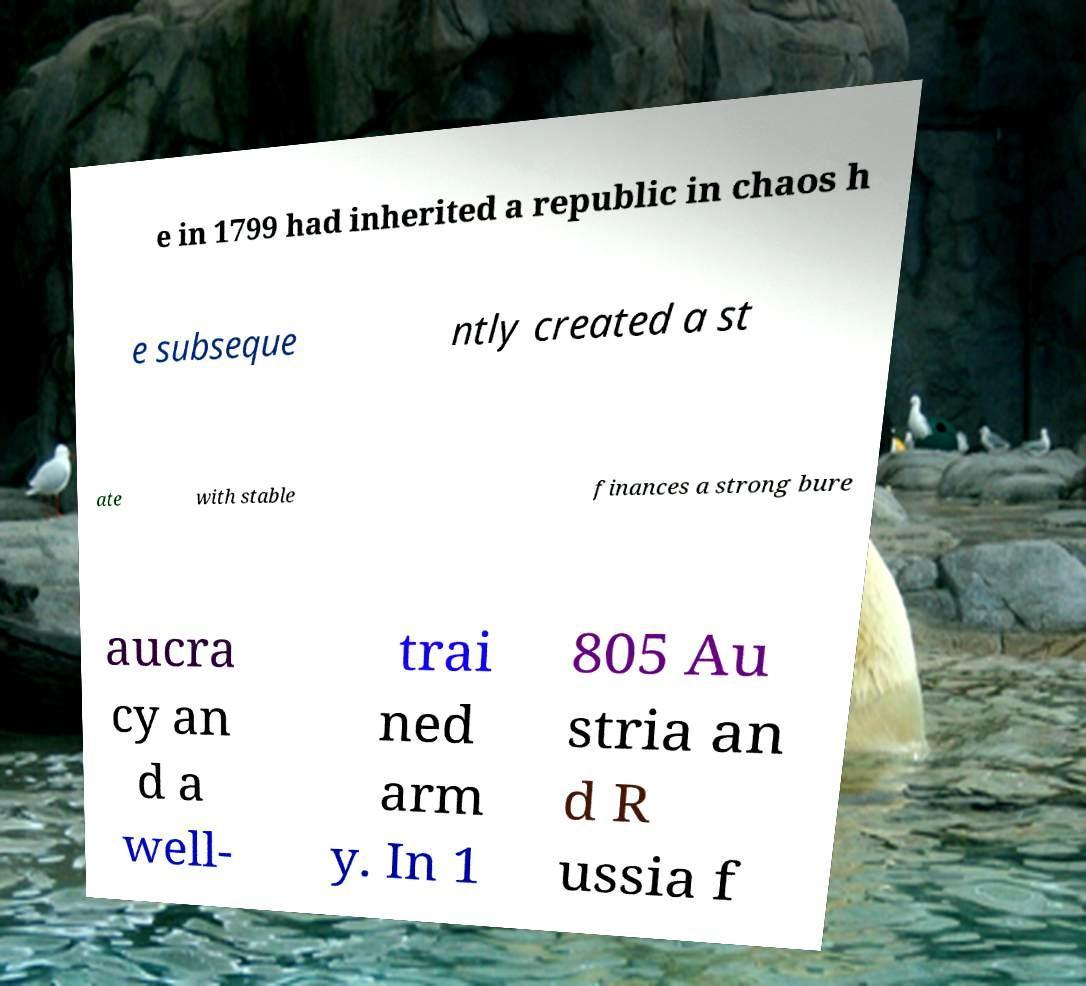Could you assist in decoding the text presented in this image and type it out clearly? e in 1799 had inherited a republic in chaos h e subseque ntly created a st ate with stable finances a strong bure aucra cy an d a well- trai ned arm y. In 1 805 Au stria an d R ussia f 